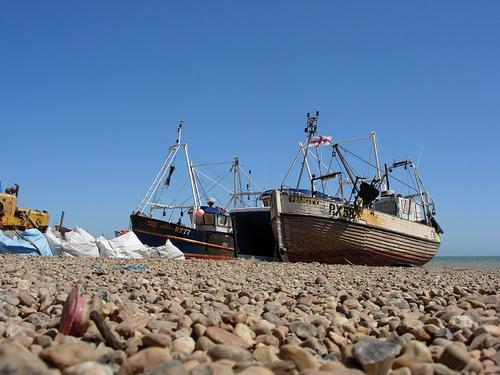How many boats are in the photo?
Give a very brief answer. 2. 